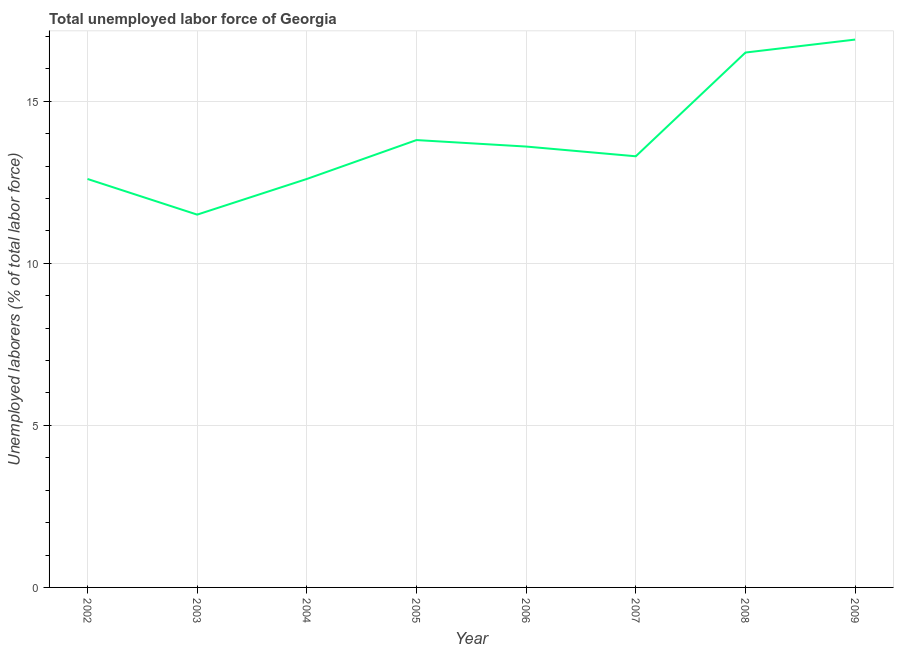What is the total unemployed labour force in 2004?
Your answer should be very brief. 12.6. Across all years, what is the maximum total unemployed labour force?
Offer a very short reply. 16.9. In which year was the total unemployed labour force maximum?
Offer a very short reply. 2009. What is the sum of the total unemployed labour force?
Keep it short and to the point. 110.8. What is the difference between the total unemployed labour force in 2008 and 2009?
Ensure brevity in your answer.  -0.4. What is the average total unemployed labour force per year?
Provide a short and direct response. 13.85. What is the median total unemployed labour force?
Give a very brief answer. 13.45. In how many years, is the total unemployed labour force greater than 10 %?
Provide a succinct answer. 8. What is the ratio of the total unemployed labour force in 2006 to that in 2007?
Make the answer very short. 1.02. Is the total unemployed labour force in 2004 less than that in 2007?
Your answer should be very brief. Yes. Is the difference between the total unemployed labour force in 2005 and 2008 greater than the difference between any two years?
Ensure brevity in your answer.  No. What is the difference between the highest and the second highest total unemployed labour force?
Your answer should be very brief. 0.4. Is the sum of the total unemployed labour force in 2004 and 2006 greater than the maximum total unemployed labour force across all years?
Your answer should be very brief. Yes. What is the difference between the highest and the lowest total unemployed labour force?
Give a very brief answer. 5.4. In how many years, is the total unemployed labour force greater than the average total unemployed labour force taken over all years?
Give a very brief answer. 2. Does the total unemployed labour force monotonically increase over the years?
Offer a very short reply. No. How many lines are there?
Provide a succinct answer. 1. What is the difference between two consecutive major ticks on the Y-axis?
Your answer should be compact. 5. Are the values on the major ticks of Y-axis written in scientific E-notation?
Ensure brevity in your answer.  No. Does the graph contain any zero values?
Your answer should be compact. No. What is the title of the graph?
Your answer should be compact. Total unemployed labor force of Georgia. What is the label or title of the Y-axis?
Offer a very short reply. Unemployed laborers (% of total labor force). What is the Unemployed laborers (% of total labor force) of 2002?
Give a very brief answer. 12.6. What is the Unemployed laborers (% of total labor force) in 2003?
Give a very brief answer. 11.5. What is the Unemployed laborers (% of total labor force) in 2004?
Provide a short and direct response. 12.6. What is the Unemployed laborers (% of total labor force) of 2005?
Your response must be concise. 13.8. What is the Unemployed laborers (% of total labor force) in 2006?
Give a very brief answer. 13.6. What is the Unemployed laborers (% of total labor force) of 2007?
Keep it short and to the point. 13.3. What is the Unemployed laborers (% of total labor force) of 2008?
Your response must be concise. 16.5. What is the Unemployed laborers (% of total labor force) in 2009?
Your answer should be very brief. 16.9. What is the difference between the Unemployed laborers (% of total labor force) in 2002 and 2003?
Provide a short and direct response. 1.1. What is the difference between the Unemployed laborers (% of total labor force) in 2002 and 2004?
Give a very brief answer. 0. What is the difference between the Unemployed laborers (% of total labor force) in 2002 and 2006?
Offer a terse response. -1. What is the difference between the Unemployed laborers (% of total labor force) in 2002 and 2009?
Provide a short and direct response. -4.3. What is the difference between the Unemployed laborers (% of total labor force) in 2003 and 2006?
Give a very brief answer. -2.1. What is the difference between the Unemployed laborers (% of total labor force) in 2003 and 2007?
Ensure brevity in your answer.  -1.8. What is the difference between the Unemployed laborers (% of total labor force) in 2003 and 2009?
Provide a short and direct response. -5.4. What is the difference between the Unemployed laborers (% of total labor force) in 2004 and 2008?
Your answer should be very brief. -3.9. What is the difference between the Unemployed laborers (% of total labor force) in 2004 and 2009?
Offer a very short reply. -4.3. What is the difference between the Unemployed laborers (% of total labor force) in 2005 and 2008?
Keep it short and to the point. -2.7. What is the difference between the Unemployed laborers (% of total labor force) in 2005 and 2009?
Give a very brief answer. -3.1. What is the difference between the Unemployed laborers (% of total labor force) in 2006 and 2007?
Keep it short and to the point. 0.3. What is the difference between the Unemployed laborers (% of total labor force) in 2007 and 2008?
Provide a succinct answer. -3.2. What is the difference between the Unemployed laborers (% of total labor force) in 2007 and 2009?
Offer a terse response. -3.6. What is the ratio of the Unemployed laborers (% of total labor force) in 2002 to that in 2003?
Offer a terse response. 1.1. What is the ratio of the Unemployed laborers (% of total labor force) in 2002 to that in 2006?
Your answer should be very brief. 0.93. What is the ratio of the Unemployed laborers (% of total labor force) in 2002 to that in 2007?
Your answer should be compact. 0.95. What is the ratio of the Unemployed laborers (% of total labor force) in 2002 to that in 2008?
Keep it short and to the point. 0.76. What is the ratio of the Unemployed laborers (% of total labor force) in 2002 to that in 2009?
Provide a short and direct response. 0.75. What is the ratio of the Unemployed laborers (% of total labor force) in 2003 to that in 2004?
Your answer should be very brief. 0.91. What is the ratio of the Unemployed laborers (% of total labor force) in 2003 to that in 2005?
Ensure brevity in your answer.  0.83. What is the ratio of the Unemployed laborers (% of total labor force) in 2003 to that in 2006?
Your response must be concise. 0.85. What is the ratio of the Unemployed laborers (% of total labor force) in 2003 to that in 2007?
Your response must be concise. 0.86. What is the ratio of the Unemployed laborers (% of total labor force) in 2003 to that in 2008?
Give a very brief answer. 0.7. What is the ratio of the Unemployed laborers (% of total labor force) in 2003 to that in 2009?
Make the answer very short. 0.68. What is the ratio of the Unemployed laborers (% of total labor force) in 2004 to that in 2006?
Provide a succinct answer. 0.93. What is the ratio of the Unemployed laborers (% of total labor force) in 2004 to that in 2007?
Offer a very short reply. 0.95. What is the ratio of the Unemployed laborers (% of total labor force) in 2004 to that in 2008?
Offer a terse response. 0.76. What is the ratio of the Unemployed laborers (% of total labor force) in 2004 to that in 2009?
Keep it short and to the point. 0.75. What is the ratio of the Unemployed laborers (% of total labor force) in 2005 to that in 2007?
Offer a very short reply. 1.04. What is the ratio of the Unemployed laborers (% of total labor force) in 2005 to that in 2008?
Ensure brevity in your answer.  0.84. What is the ratio of the Unemployed laborers (% of total labor force) in 2005 to that in 2009?
Provide a short and direct response. 0.82. What is the ratio of the Unemployed laborers (% of total labor force) in 2006 to that in 2008?
Your answer should be compact. 0.82. What is the ratio of the Unemployed laborers (% of total labor force) in 2006 to that in 2009?
Offer a very short reply. 0.81. What is the ratio of the Unemployed laborers (% of total labor force) in 2007 to that in 2008?
Your response must be concise. 0.81. What is the ratio of the Unemployed laborers (% of total labor force) in 2007 to that in 2009?
Provide a succinct answer. 0.79. 